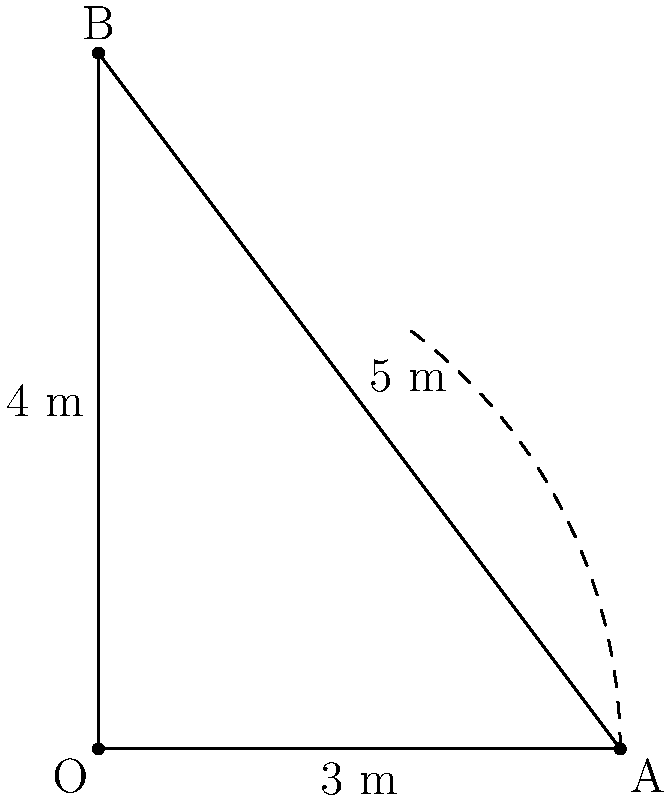You are helping an artist transport a large conical sculpture. The sculpture has a base radius of 3 meters and a height of 4 meters. The artist wants to paint the entire surface of the cone, including the base. Estimate the amount of paint needed in liters if 1 liter of paint covers approximately 4 square meters. Round your answer to the nearest whole liter. To solve this problem, we need to follow these steps:

1. Calculate the surface area of the cone (lateral surface + base)
2. Convert the surface area to the amount of paint needed

Step 1: Calculate the surface area

a) Lateral surface area:
   First, we need to find the slant height (l) using the Pythagorean theorem:
   $$l = \sqrt{r^2 + h^2} = \sqrt{3^2 + 4^2} = \sqrt{9 + 16} = \sqrt{25} = 5\text{ m}$$
   
   Lateral surface area = $\pi r l$
   $$A_{\text{lateral}} = \pi \cdot 3 \cdot 5 = 15\pi\text{ m}^2$$

b) Base area:
   $$A_{\text{base}} = \pi r^2 = \pi \cdot 3^2 = 9\pi\text{ m}^2$$

c) Total surface area:
   $$A_{\text{total}} = A_{\text{lateral}} + A_{\text{base}} = 15\pi + 9\pi = 24\pi\text{ m}^2$$

Step 2: Convert surface area to paint needed

Given that 1 liter covers 4 square meters:
$$\text{Paint needed} = \frac{24\pi\text{ m}^2}{4\text{ m}^2/\text{L}} = 6\pi\text{ L} \approx 18.85\text{ L}$$

Rounding to the nearest whole liter: 19 L
Answer: 19 L 